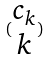<formula> <loc_0><loc_0><loc_500><loc_500>( \begin{matrix} c _ { k } \\ k \end{matrix} )</formula> 